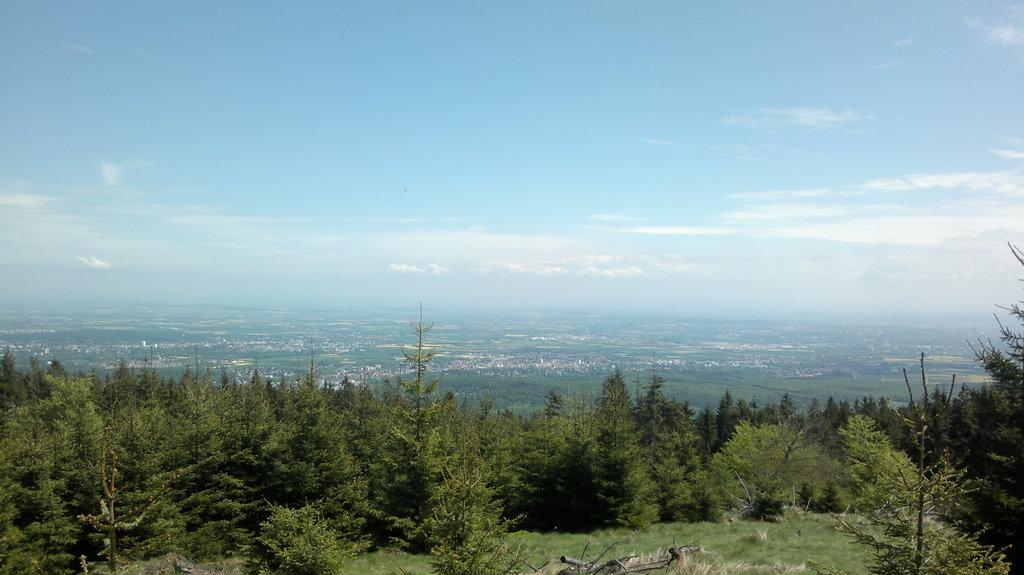What type of vegetation can be seen in the image? There are trees in the image. What is visible in the background of the image? The sky is visible in the background of the image. What can be observed in the sky? Clouds are present in the sky. What type of vegetable is being used as a lock in the image? There is no vegetable being used as a lock in the image, as the facts provided do not mention any locks or vegetables. 